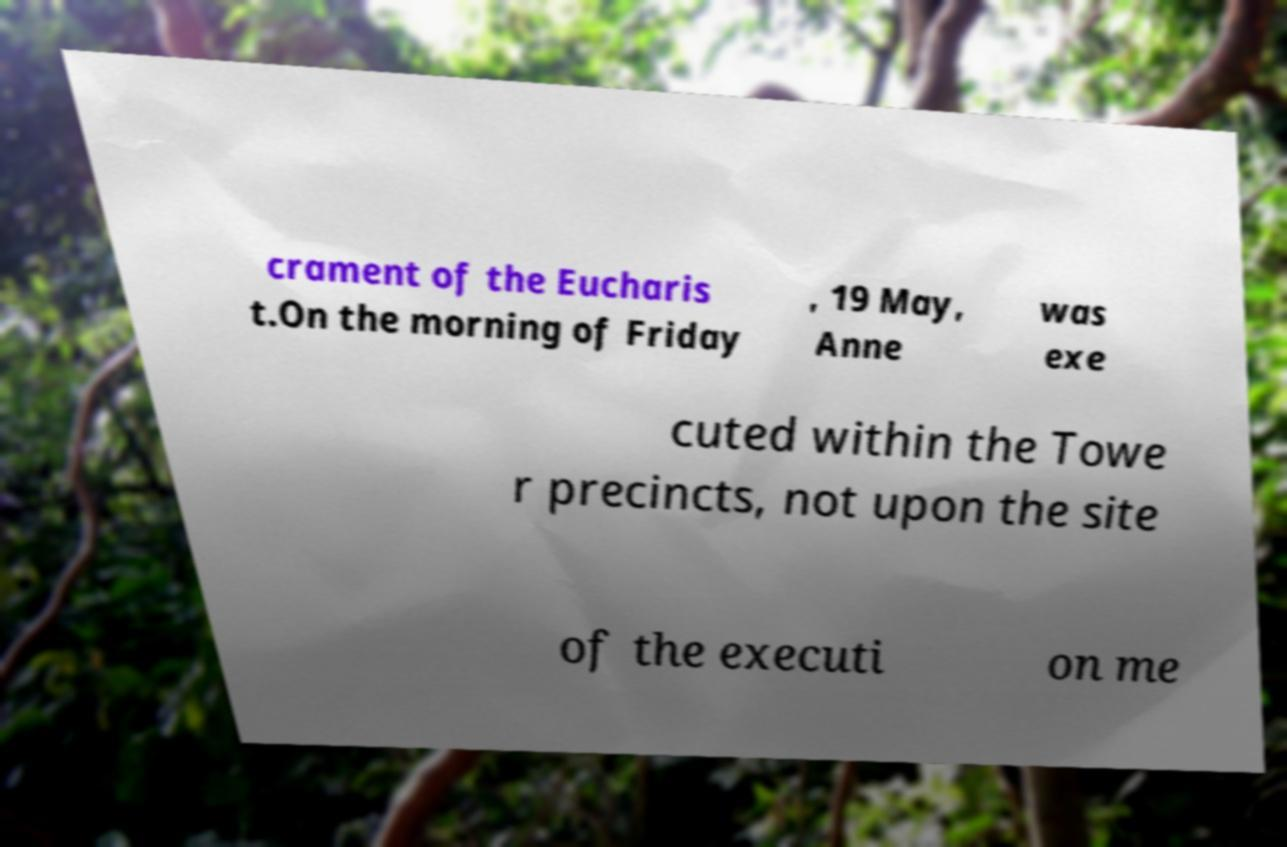Can you accurately transcribe the text from the provided image for me? crament of the Eucharis t.On the morning of Friday , 19 May, Anne was exe cuted within the Towe r precincts, not upon the site of the executi on me 